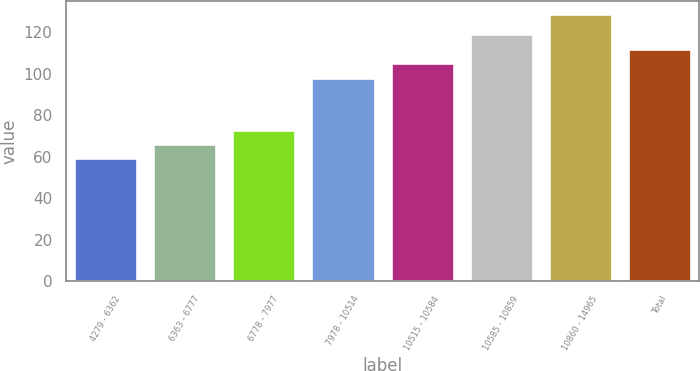<chart> <loc_0><loc_0><loc_500><loc_500><bar_chart><fcel>4279 - 6362<fcel>6363 - 6777<fcel>6778 - 7977<fcel>7978 - 10514<fcel>10515 - 10584<fcel>10585 - 10859<fcel>10860 - 14965<fcel>Total<nl><fcel>59.22<fcel>66.16<fcel>73.1<fcel>98.17<fcel>105.18<fcel>119.06<fcel>128.65<fcel>112.12<nl></chart> 